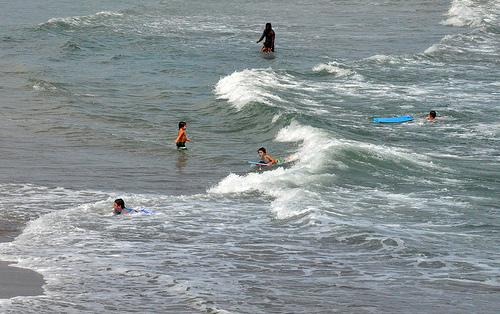What color are the surfboards? The surfboards are bright blue. What activity are some people participating in at the beach? Some people are surfing in the ocean waves using blue surfboards. Briefly describe the person lying on the board. The person lying on the board appears to be a young boy in a blue wetsuit with short, brown hair. What is the general mood of the people in the image? The people in the image seem to be enjoying their time in the ocean water, participating in various activities. What is the overall scene presented in the image? The image shows a beach scene with multiple people enjoying the ocean water, surfing on blue surfboards, and some standing or lying on the sand. Describe the waves in the ocean. The ocean waves have white caps, with some small shallow waves and beach waves washing up onto the sand. What is the person standing in the water wearing? The person standing in the water is wearing swim trunks and no shirt. How many people can be seen in the water? There are at least five people in the water at the ocean. What is the condition of the beach sand? The beach sand appears to be wet in some areas. What type of water is the beach located in? The beach is located in salt water. Are the people lying on the beach sunbathing while holding umbrellas? No, it's not mentioned in the image. 